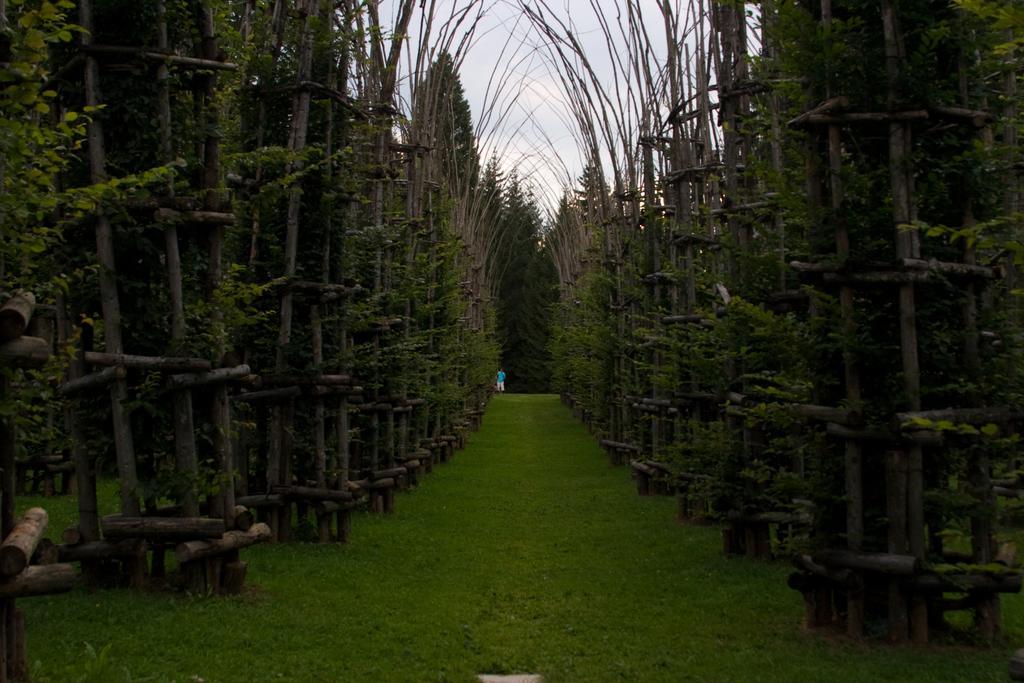How would you summarize this image in a sentence or two? In this image we can see a group of trees beside the wooden fence. We can also see a person standing on the grass. On the backside we can see the sky which looks cloudy. 